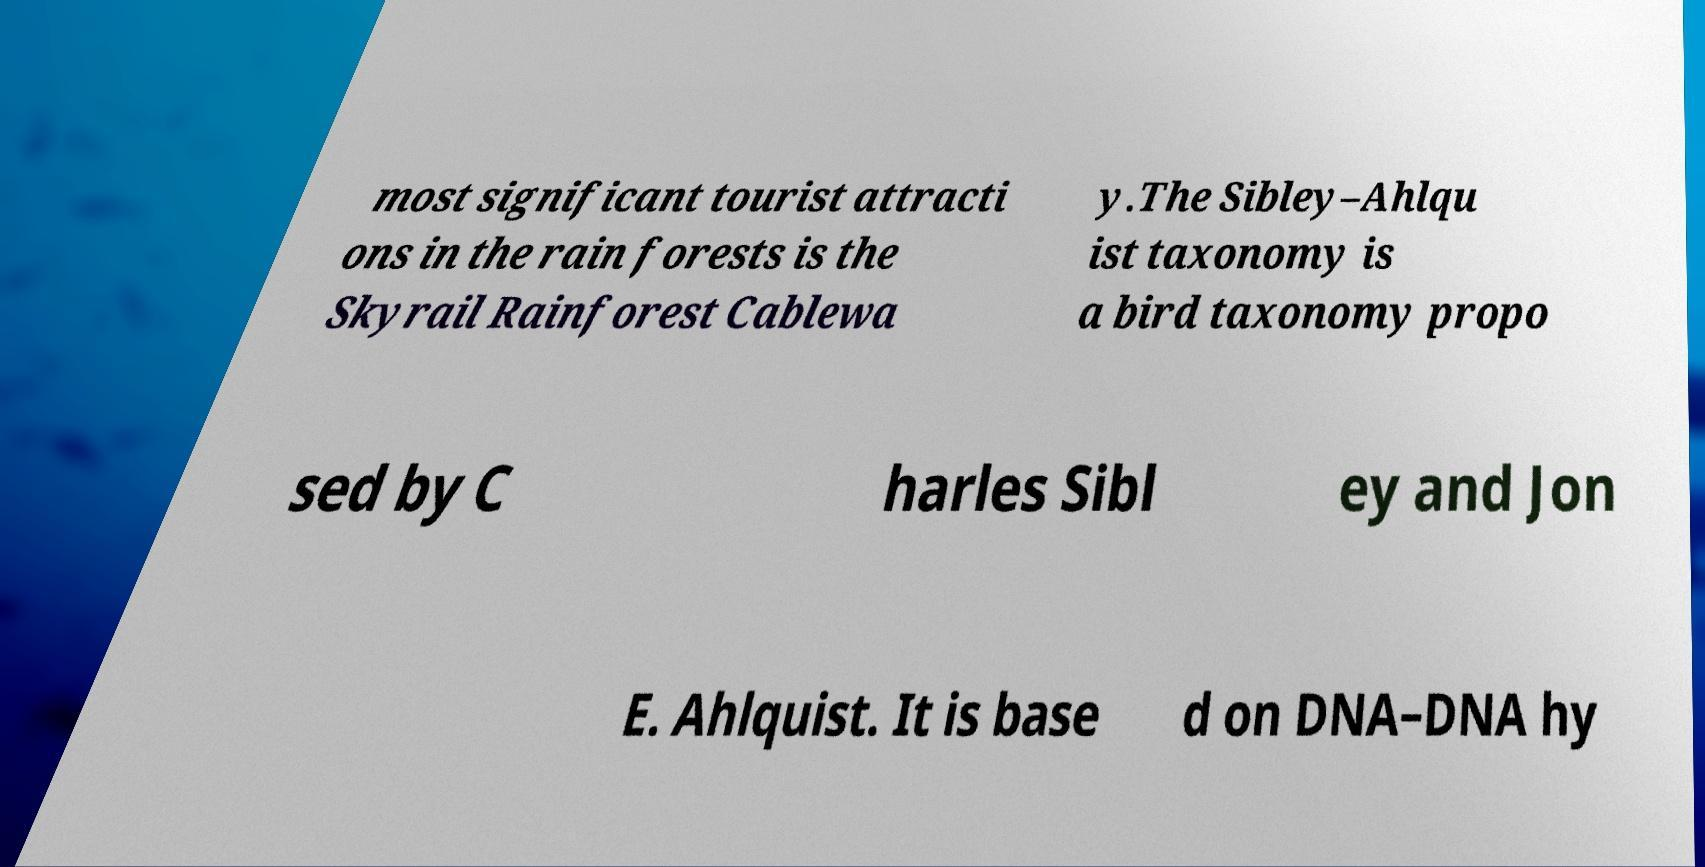There's text embedded in this image that I need extracted. Can you transcribe it verbatim? most significant tourist attracti ons in the rain forests is the Skyrail Rainforest Cablewa y.The Sibley–Ahlqu ist taxonomy is a bird taxonomy propo sed by C harles Sibl ey and Jon E. Ahlquist. It is base d on DNA–DNA hy 